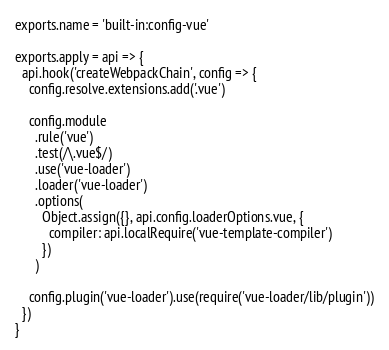Convert code to text. <code><loc_0><loc_0><loc_500><loc_500><_JavaScript_>exports.name = 'built-in:config-vue'

exports.apply = api => {
  api.hook('createWebpackChain', config => {
    config.resolve.extensions.add('.vue')

    config.module
      .rule('vue')
      .test(/\.vue$/)
      .use('vue-loader')
      .loader('vue-loader')
      .options(
        Object.assign({}, api.config.loaderOptions.vue, {
          compiler: api.localRequire('vue-template-compiler')
        })
      )

    config.plugin('vue-loader').use(require('vue-loader/lib/plugin'))
  })
}
</code> 